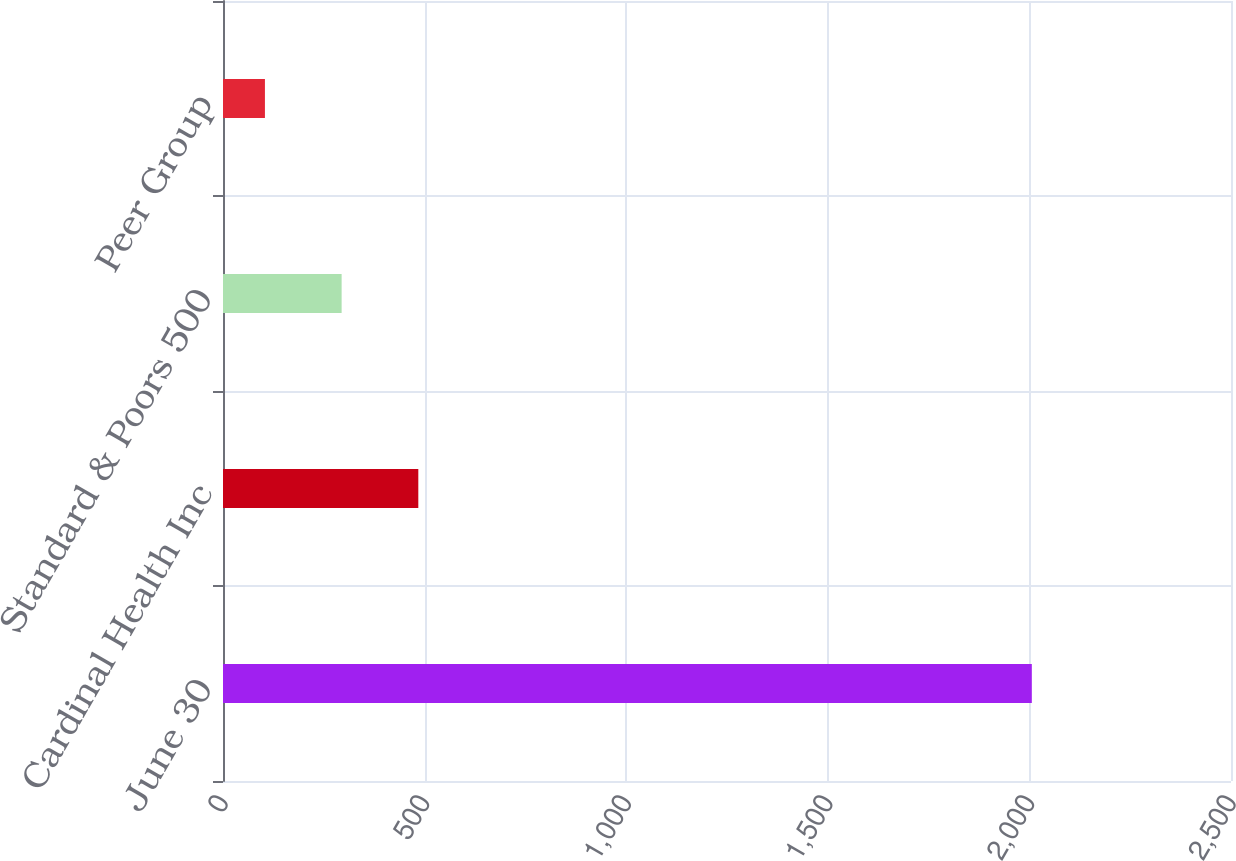Convert chart to OTSL. <chart><loc_0><loc_0><loc_500><loc_500><bar_chart><fcel>June 30<fcel>Cardinal Health Inc<fcel>Standard & Poors 500<fcel>Peer Group<nl><fcel>2006<fcel>484.4<fcel>294.2<fcel>104<nl></chart> 